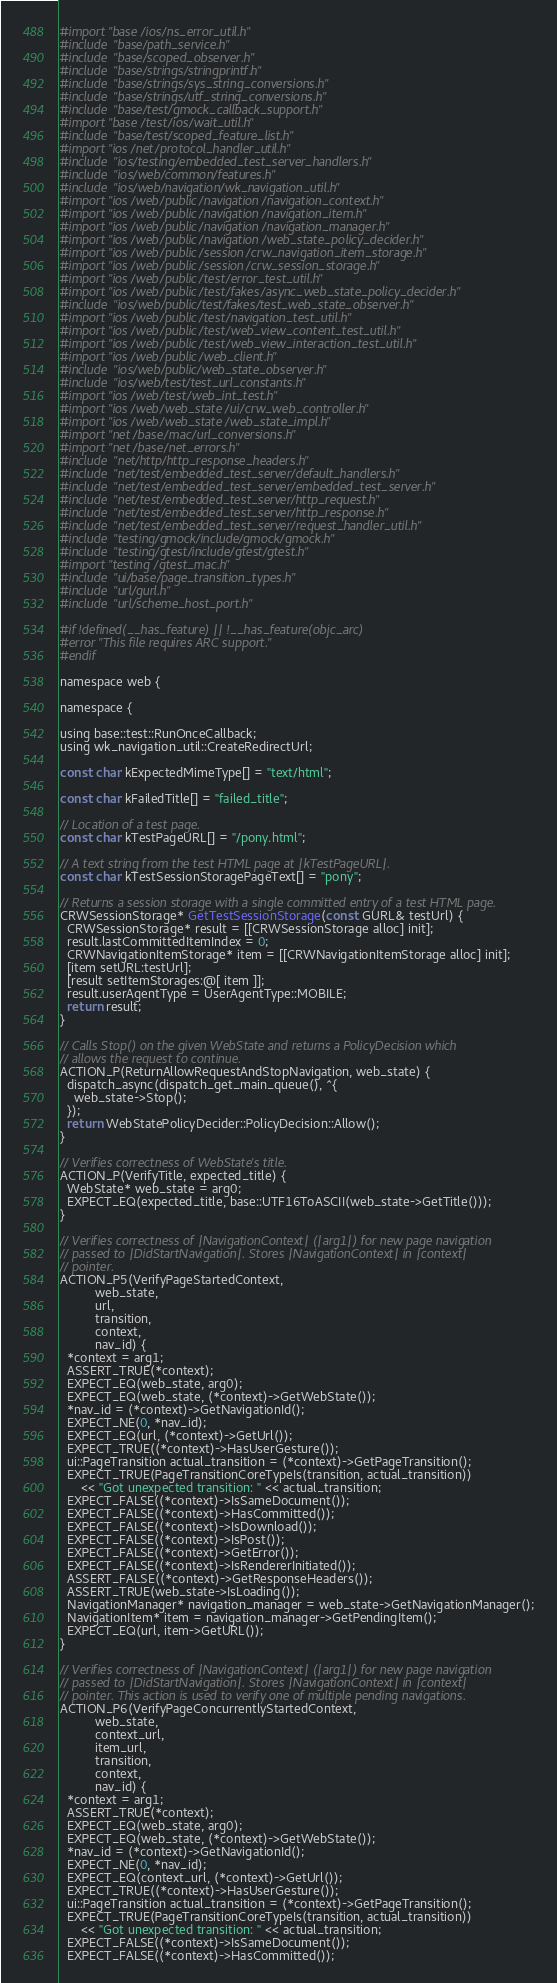Convert code to text. <code><loc_0><loc_0><loc_500><loc_500><_ObjectiveC_>#import "base/ios/ns_error_util.h"
#include "base/path_service.h"
#include "base/scoped_observer.h"
#include "base/strings/stringprintf.h"
#include "base/strings/sys_string_conversions.h"
#include "base/strings/utf_string_conversions.h"
#include "base/test/gmock_callback_support.h"
#import "base/test/ios/wait_util.h"
#include "base/test/scoped_feature_list.h"
#import "ios/net/protocol_handler_util.h"
#include "ios/testing/embedded_test_server_handlers.h"
#include "ios/web/common/features.h"
#include "ios/web/navigation/wk_navigation_util.h"
#import "ios/web/public/navigation/navigation_context.h"
#import "ios/web/public/navigation/navigation_item.h"
#import "ios/web/public/navigation/navigation_manager.h"
#import "ios/web/public/navigation/web_state_policy_decider.h"
#import "ios/web/public/session/crw_navigation_item_storage.h"
#import "ios/web/public/session/crw_session_storage.h"
#import "ios/web/public/test/error_test_util.h"
#import "ios/web/public/test/fakes/async_web_state_policy_decider.h"
#include "ios/web/public/test/fakes/test_web_state_observer.h"
#import "ios/web/public/test/navigation_test_util.h"
#import "ios/web/public/test/web_view_content_test_util.h"
#import "ios/web/public/test/web_view_interaction_test_util.h"
#import "ios/web/public/web_client.h"
#include "ios/web/public/web_state_observer.h"
#include "ios/web/test/test_url_constants.h"
#import "ios/web/test/web_int_test.h"
#import "ios/web/web_state/ui/crw_web_controller.h"
#import "ios/web/web_state/web_state_impl.h"
#import "net/base/mac/url_conversions.h"
#import "net/base/net_errors.h"
#include "net/http/http_response_headers.h"
#include "net/test/embedded_test_server/default_handlers.h"
#include "net/test/embedded_test_server/embedded_test_server.h"
#include "net/test/embedded_test_server/http_request.h"
#include "net/test/embedded_test_server/http_response.h"
#include "net/test/embedded_test_server/request_handler_util.h"
#include "testing/gmock/include/gmock/gmock.h"
#include "testing/gtest/include/gtest/gtest.h"
#import "testing/gtest_mac.h"
#include "ui/base/page_transition_types.h"
#include "url/gurl.h"
#include "url/scheme_host_port.h"

#if !defined(__has_feature) || !__has_feature(objc_arc)
#error "This file requires ARC support."
#endif

namespace web {

namespace {

using base::test::RunOnceCallback;
using wk_navigation_util::CreateRedirectUrl;

const char kExpectedMimeType[] = "text/html";

const char kFailedTitle[] = "failed_title";

// Location of a test page.
const char kTestPageURL[] = "/pony.html";

// A text string from the test HTML page at |kTestPageURL|.
const char kTestSessionStoragePageText[] = "pony";

// Returns a session storage with a single committed entry of a test HTML page.
CRWSessionStorage* GetTestSessionStorage(const GURL& testUrl) {
  CRWSessionStorage* result = [[CRWSessionStorage alloc] init];
  result.lastCommittedItemIndex = 0;
  CRWNavigationItemStorage* item = [[CRWNavigationItemStorage alloc] init];
  [item setURL:testUrl];
  [result setItemStorages:@[ item ]];
  result.userAgentType = UserAgentType::MOBILE;
  return result;
}

// Calls Stop() on the given WebState and returns a PolicyDecision which
// allows the request to continue.
ACTION_P(ReturnAllowRequestAndStopNavigation, web_state) {
  dispatch_async(dispatch_get_main_queue(), ^{
    web_state->Stop();
  });
  return WebStatePolicyDecider::PolicyDecision::Allow();
}

// Verifies correctness of WebState's title.
ACTION_P(VerifyTitle, expected_title) {
  WebState* web_state = arg0;
  EXPECT_EQ(expected_title, base::UTF16ToASCII(web_state->GetTitle()));
}

// Verifies correctness of |NavigationContext| (|arg1|) for new page navigation
// passed to |DidStartNavigation|. Stores |NavigationContext| in |context|
// pointer.
ACTION_P5(VerifyPageStartedContext,
          web_state,
          url,
          transition,
          context,
          nav_id) {
  *context = arg1;
  ASSERT_TRUE(*context);
  EXPECT_EQ(web_state, arg0);
  EXPECT_EQ(web_state, (*context)->GetWebState());
  *nav_id = (*context)->GetNavigationId();
  EXPECT_NE(0, *nav_id);
  EXPECT_EQ(url, (*context)->GetUrl());
  EXPECT_TRUE((*context)->HasUserGesture());
  ui::PageTransition actual_transition = (*context)->GetPageTransition();
  EXPECT_TRUE(PageTransitionCoreTypeIs(transition, actual_transition))
      << "Got unexpected transition: " << actual_transition;
  EXPECT_FALSE((*context)->IsSameDocument());
  EXPECT_FALSE((*context)->HasCommitted());
  EXPECT_FALSE((*context)->IsDownload());
  EXPECT_FALSE((*context)->IsPost());
  EXPECT_FALSE((*context)->GetError());
  EXPECT_FALSE((*context)->IsRendererInitiated());
  ASSERT_FALSE((*context)->GetResponseHeaders());
  ASSERT_TRUE(web_state->IsLoading());
  NavigationManager* navigation_manager = web_state->GetNavigationManager();
  NavigationItem* item = navigation_manager->GetPendingItem();
  EXPECT_EQ(url, item->GetURL());
}

// Verifies correctness of |NavigationContext| (|arg1|) for new page navigation
// passed to |DidStartNavigation|. Stores |NavigationContext| in |context|
// pointer. This action is used to verify one of multiple pending navigations.
ACTION_P6(VerifyPageConcurrentlyStartedContext,
          web_state,
          context_url,
          item_url,
          transition,
          context,
          nav_id) {
  *context = arg1;
  ASSERT_TRUE(*context);
  EXPECT_EQ(web_state, arg0);
  EXPECT_EQ(web_state, (*context)->GetWebState());
  *nav_id = (*context)->GetNavigationId();
  EXPECT_NE(0, *nav_id);
  EXPECT_EQ(context_url, (*context)->GetUrl());
  EXPECT_TRUE((*context)->HasUserGesture());
  ui::PageTransition actual_transition = (*context)->GetPageTransition();
  EXPECT_TRUE(PageTransitionCoreTypeIs(transition, actual_transition))
      << "Got unexpected transition: " << actual_transition;
  EXPECT_FALSE((*context)->IsSameDocument());
  EXPECT_FALSE((*context)->HasCommitted());</code> 